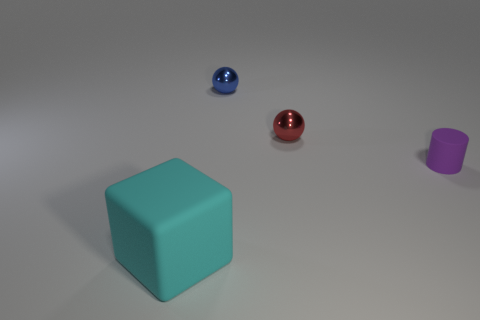Add 4 metallic cylinders. How many objects exist? 8 Add 3 small purple rubber cylinders. How many small purple rubber cylinders exist? 4 Subtract 0 blue blocks. How many objects are left? 4 Subtract all tiny purple rubber cylinders. Subtract all big green objects. How many objects are left? 3 Add 2 big cubes. How many big cubes are left? 3 